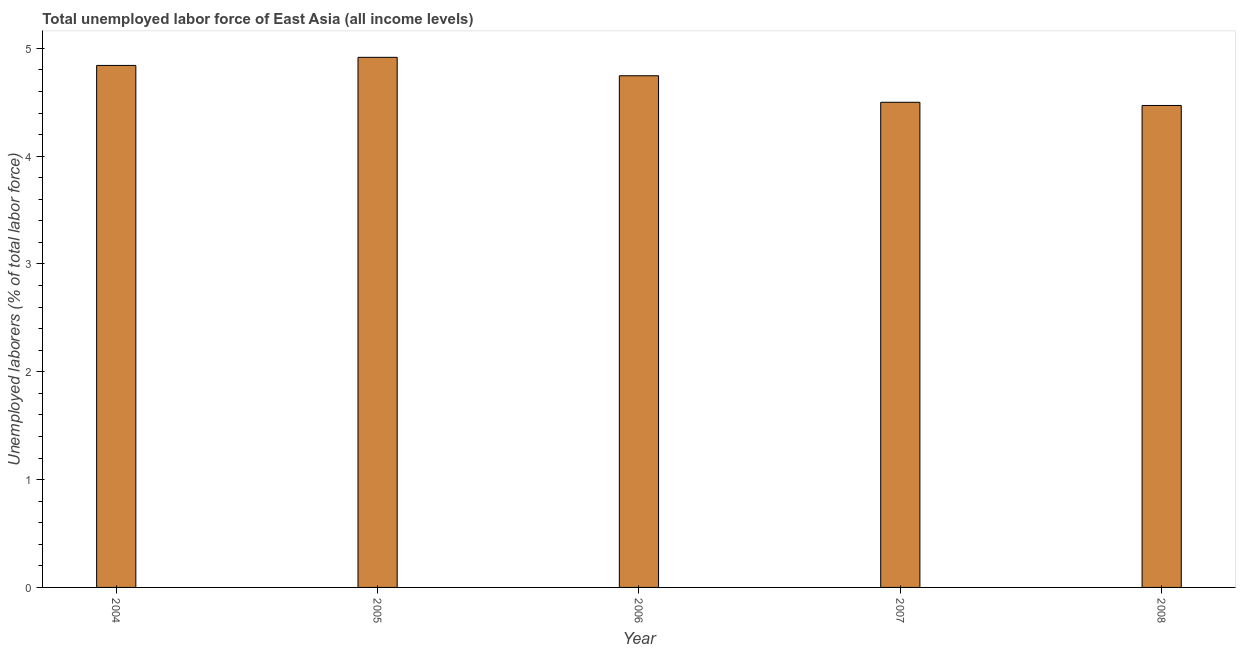Does the graph contain any zero values?
Your response must be concise. No. What is the title of the graph?
Keep it short and to the point. Total unemployed labor force of East Asia (all income levels). What is the label or title of the X-axis?
Provide a short and direct response. Year. What is the label or title of the Y-axis?
Keep it short and to the point. Unemployed laborers (% of total labor force). What is the total unemployed labour force in 2007?
Ensure brevity in your answer.  4.5. Across all years, what is the maximum total unemployed labour force?
Your answer should be compact. 4.92. Across all years, what is the minimum total unemployed labour force?
Your response must be concise. 4.47. What is the sum of the total unemployed labour force?
Your answer should be compact. 23.47. What is the difference between the total unemployed labour force in 2007 and 2008?
Your response must be concise. 0.03. What is the average total unemployed labour force per year?
Offer a very short reply. 4.7. What is the median total unemployed labour force?
Your answer should be very brief. 4.75. In how many years, is the total unemployed labour force greater than 2.6 %?
Your answer should be compact. 5. Do a majority of the years between 2006 and 2004 (inclusive) have total unemployed labour force greater than 4.4 %?
Your answer should be very brief. Yes. What is the ratio of the total unemployed labour force in 2005 to that in 2006?
Offer a terse response. 1.04. Is the total unemployed labour force in 2005 less than that in 2007?
Make the answer very short. No. Is the difference between the total unemployed labour force in 2005 and 2007 greater than the difference between any two years?
Ensure brevity in your answer.  No. What is the difference between the highest and the second highest total unemployed labour force?
Provide a succinct answer. 0.07. What is the difference between the highest and the lowest total unemployed labour force?
Give a very brief answer. 0.45. In how many years, is the total unemployed labour force greater than the average total unemployed labour force taken over all years?
Make the answer very short. 3. How many bars are there?
Keep it short and to the point. 5. Are all the bars in the graph horizontal?
Provide a succinct answer. No. How many years are there in the graph?
Offer a very short reply. 5. Are the values on the major ticks of Y-axis written in scientific E-notation?
Provide a succinct answer. No. What is the Unemployed laborers (% of total labor force) in 2004?
Ensure brevity in your answer.  4.84. What is the Unemployed laborers (% of total labor force) in 2005?
Keep it short and to the point. 4.92. What is the Unemployed laborers (% of total labor force) in 2006?
Offer a terse response. 4.75. What is the Unemployed laborers (% of total labor force) in 2007?
Give a very brief answer. 4.5. What is the Unemployed laborers (% of total labor force) of 2008?
Your answer should be compact. 4.47. What is the difference between the Unemployed laborers (% of total labor force) in 2004 and 2005?
Provide a short and direct response. -0.08. What is the difference between the Unemployed laborers (% of total labor force) in 2004 and 2006?
Provide a short and direct response. 0.1. What is the difference between the Unemployed laborers (% of total labor force) in 2004 and 2007?
Your answer should be very brief. 0.34. What is the difference between the Unemployed laborers (% of total labor force) in 2004 and 2008?
Offer a very short reply. 0.37. What is the difference between the Unemployed laborers (% of total labor force) in 2005 and 2006?
Offer a very short reply. 0.17. What is the difference between the Unemployed laborers (% of total labor force) in 2005 and 2007?
Make the answer very short. 0.42. What is the difference between the Unemployed laborers (% of total labor force) in 2005 and 2008?
Offer a terse response. 0.45. What is the difference between the Unemployed laborers (% of total labor force) in 2006 and 2007?
Give a very brief answer. 0.25. What is the difference between the Unemployed laborers (% of total labor force) in 2006 and 2008?
Keep it short and to the point. 0.28. What is the difference between the Unemployed laborers (% of total labor force) in 2007 and 2008?
Provide a short and direct response. 0.03. What is the ratio of the Unemployed laborers (% of total labor force) in 2004 to that in 2005?
Offer a terse response. 0.98. What is the ratio of the Unemployed laborers (% of total labor force) in 2004 to that in 2006?
Provide a succinct answer. 1.02. What is the ratio of the Unemployed laborers (% of total labor force) in 2004 to that in 2007?
Make the answer very short. 1.08. What is the ratio of the Unemployed laborers (% of total labor force) in 2004 to that in 2008?
Give a very brief answer. 1.08. What is the ratio of the Unemployed laborers (% of total labor force) in 2005 to that in 2006?
Your answer should be very brief. 1.04. What is the ratio of the Unemployed laborers (% of total labor force) in 2005 to that in 2007?
Ensure brevity in your answer.  1.09. What is the ratio of the Unemployed laborers (% of total labor force) in 2006 to that in 2007?
Make the answer very short. 1.05. What is the ratio of the Unemployed laborers (% of total labor force) in 2006 to that in 2008?
Ensure brevity in your answer.  1.06. What is the ratio of the Unemployed laborers (% of total labor force) in 2007 to that in 2008?
Your answer should be compact. 1.01. 